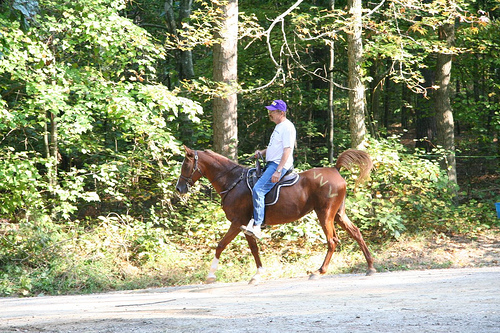Please identify all text content in this image. Z 